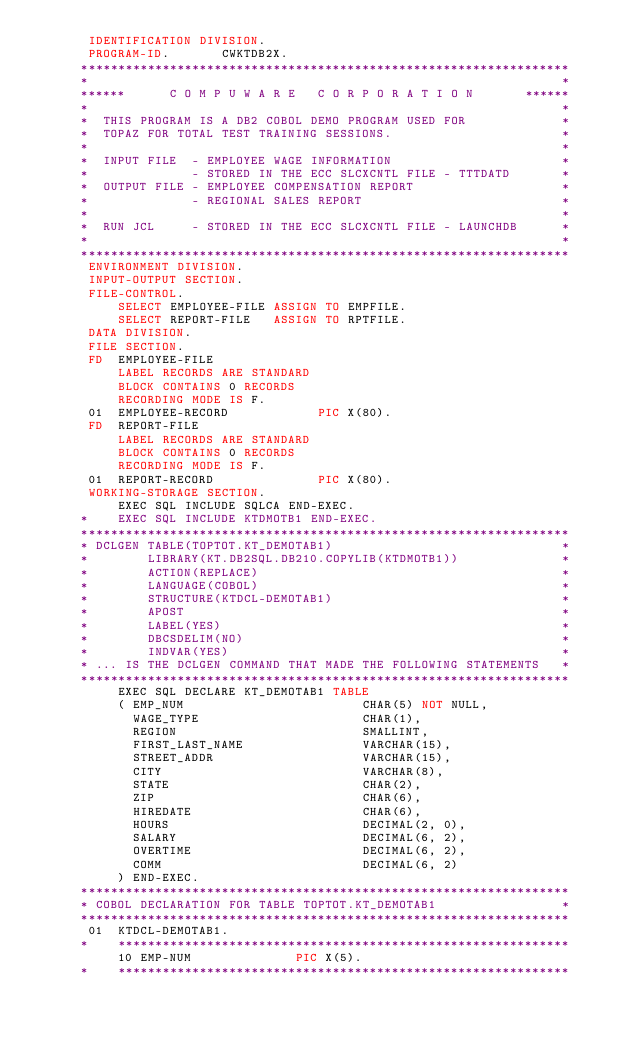<code> <loc_0><loc_0><loc_500><loc_500><_COBOL_>       IDENTIFICATION DIVISION.
       PROGRAM-ID.       CWKTDB2X.
      ******************************************************************
      *                                                                *
      ******      C O M P U W A R E   C O R P O R A T I O N       ******
      *                                                                *
      *  THIS PROGRAM IS A DB2 COBOL DEMO PROGRAM USED FOR             *
      *  TOPAZ FOR TOTAL TEST TRAINING SESSIONS.                       *
      *                                                                *
      *  INPUT FILE  - EMPLOYEE WAGE INFORMATION                       *
      *              - STORED IN THE ECC SLCXCNTL FILE - TTTDATD       *
      *  OUTPUT FILE - EMPLOYEE COMPENSATION REPORT                    *
      *              - REGIONAL SALES REPORT                           *
      *                                                                *
      *  RUN JCL     - STORED IN THE ECC SLCXCNTL FILE - LAUNCHDB      *
      *                                                                *
      ******************************************************************
       ENVIRONMENT DIVISION.
       INPUT-OUTPUT SECTION.
       FILE-CONTROL.
           SELECT EMPLOYEE-FILE ASSIGN TO EMPFILE.
           SELECT REPORT-FILE   ASSIGN TO RPTFILE.
       DATA DIVISION.
       FILE SECTION.
       FD  EMPLOYEE-FILE
           LABEL RECORDS ARE STANDARD
           BLOCK CONTAINS 0 RECORDS
           RECORDING MODE IS F.
       01  EMPLOYEE-RECORD            PIC X(80).
       FD  REPORT-FILE
           LABEL RECORDS ARE STANDARD
           BLOCK CONTAINS 0 RECORDS
           RECORDING MODE IS F.
       01  REPORT-RECORD              PIC X(80).
       WORKING-STORAGE SECTION.
           EXEC SQL INCLUDE SQLCA END-EXEC.
      *    EXEC SQL INCLUDE KTDMOTB1 END-EXEC.
      ******************************************************************
      * DCLGEN TABLE(TOPTOT.KT_DEMOTAB1)                               *
      *        LIBRARY(KT.DB2SQL.DB210.COPYLIB(KTDMOTB1))              *
      *        ACTION(REPLACE)                                         *
      *        LANGUAGE(COBOL)                                         *
      *        STRUCTURE(KTDCL-DEMOTAB1)                               *
      *        APOST                                                   *
      *        LABEL(YES)                                              *
      *        DBCSDELIM(NO)                                           *
      *        INDVAR(YES)                                             *
      * ... IS THE DCLGEN COMMAND THAT MADE THE FOLLOWING STATEMENTS   *
      ******************************************************************
           EXEC SQL DECLARE KT_DEMOTAB1 TABLE
           ( EMP_NUM                        CHAR(5) NOT NULL,
             WAGE_TYPE                      CHAR(1),
             REGION                         SMALLINT,
             FIRST_LAST_NAME                VARCHAR(15),
             STREET_ADDR                    VARCHAR(15),
             CITY                           VARCHAR(8),
             STATE                          CHAR(2),
             ZIP                            CHAR(6),
             HIREDATE                       CHAR(6),
             HOURS                          DECIMAL(2, 0),
             SALARY                         DECIMAL(6, 2),
             OVERTIME                       DECIMAL(6, 2),
             COMM                           DECIMAL(6, 2)
           ) END-EXEC.
      ******************************************************************
      * COBOL DECLARATION FOR TABLE TOPTOT.KT_DEMOTAB1                 *
      ******************************************************************
       01  KTDCL-DEMOTAB1.
      *    *************************************************************
           10 EMP-NUM              PIC X(5).
      *    *************************************************************</code> 